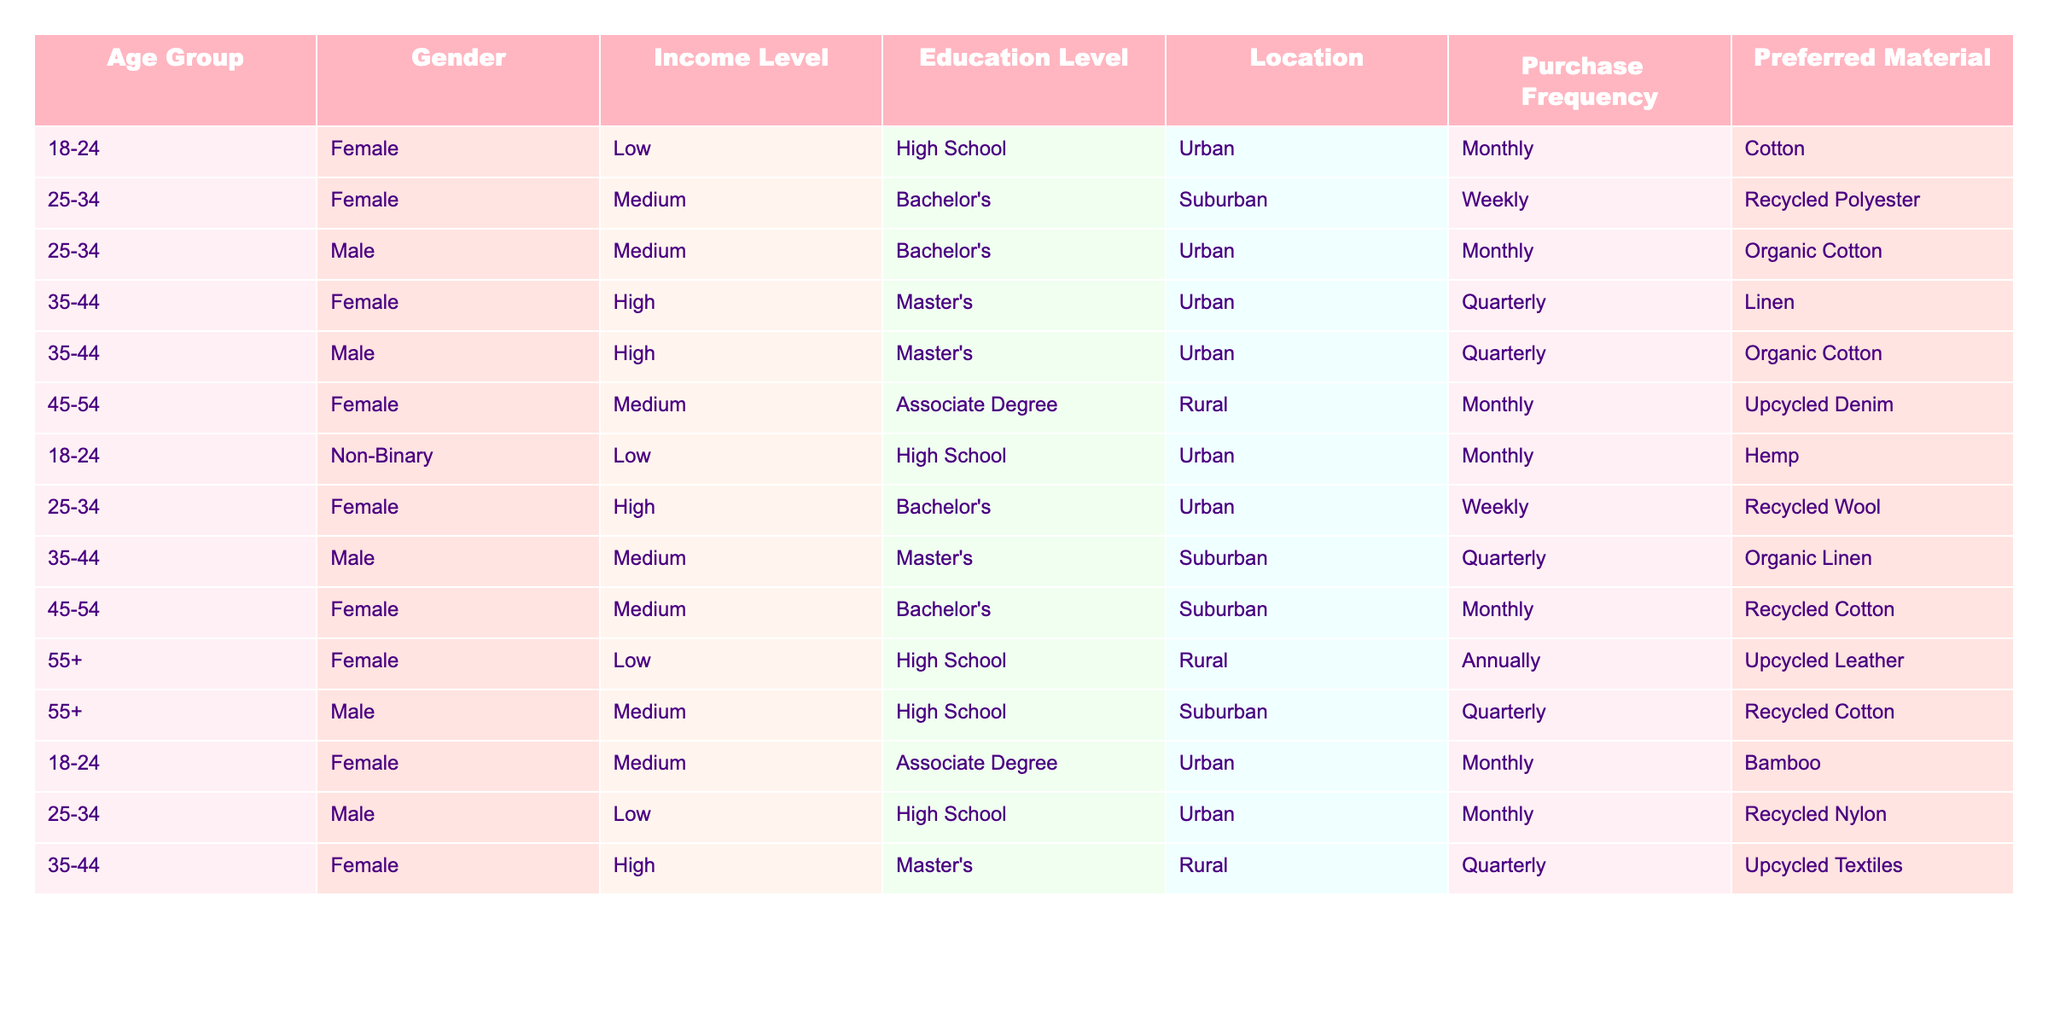What is the most common preferred material among sustainable fashion buyers in the 25-34 age group? In the 25-34 age group, the preferred materials are Recycled Polyester, Organic Cotton, Recycled Wool, and Recycled Nylon. Among these, Recycled Polyester is the most frequently mentioned.
Answer: Recycled Polyester How many female buyers are in the 35-44 age group? The table shows three female buyers in the 35-44 age group: one prefers Linen, another prefers Organic Cotton, and a third prefers Upcycled Textiles.
Answer: 3 Is there a gender that predominantly prefers upcycled materials? From the table, both females and males prefer upcycled materials, but females prefer Upcycled Denim and Upcycled Leather, whereas the males have more references to Organic Cotton. Thus, females seem to have a stronger preference for upcycled materials.
Answer: Yes What percentage of the respondents are from urban locations? By counting the occurrences, there are a total of 8 respondents from Urban locations out of 14 total respondents. The percentage is calculated as (8/14) * 100 = approximately 57.14%.
Answer: Approximately 57% What is the average income level of male buyers in the dataset? The income levels for male buyers are Medium (2 occurrences) and High (3 occurrences). To determine the average, assign numeric values: Low=1, Medium=2, High=3. Thus, (2+2+3)/3 = 2.33, which corresponds to Medium income level.
Answer: Medium Which location has the highest representation among the consumers in the dataset? Analyzing the location data, the Urban location has the highest representation with 6 entries, compared to Suburban (4) and Rural (3).
Answer: Urban How often do users from the 55+ age group purchase sustainable fashion items? The 55+ age group includes two entries: one with an annual purchase frequency and another with a quarterly frequency. Average of 1 year and 0.25 years gives a frequency of annual purchases (Annual is greater than Quarterly).
Answer: Annual What is the most preferred material for customers living in rural areas? In the Rural locations, the preferred materials are Linen (35-44 Female), Upcycled Denim (45-54 Female), and Upcycled Leather (55+ Female). The most preferred material mentioned is Linen.
Answer: Linen How many respondents prefer organic materials? The table lists Organic Cotton (2 occurrences), Organic Linen (1 occurrence) as preferred materials, leading to a total of 3 respondents.
Answer: 3 Is there a noticeable trend in purchase frequency between genders? Observing the purchase frequency, females purchase more frequently on a monthly and weekly basis compared to males, who have more quarterly purchase frequencies. This suggests females have a trend towards more frequent purchases.
Answer: Yes What is the most common education level among sustainable fashion buyers in the dataset? The education levels among the buyers indicate High School (3), Associate Degree (3), Bachelor's (4), and Master's (3). The Bachelor’s level shows the highest occurrence with 4 entries.
Answer: Bachelor's 